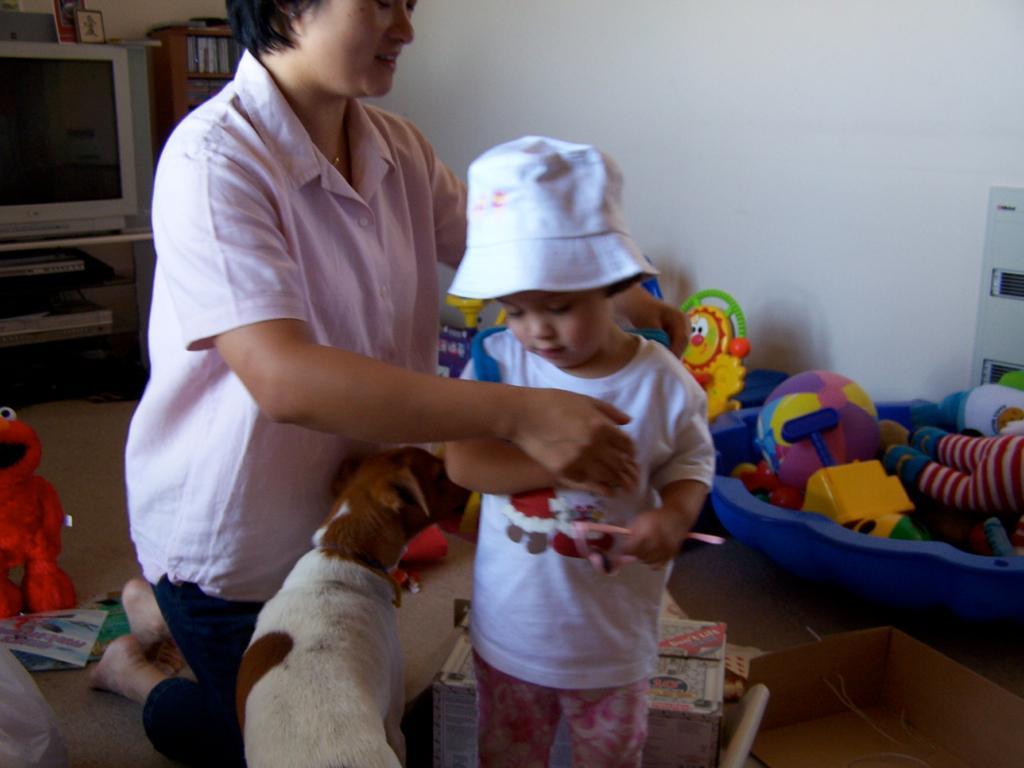In one or two sentences, can you explain what this image depicts? In this picture I can see a woman, a child and a dog in front. On the left bottom of this picture I can see a red color toy. In the background I can see many more toys and I see the wall. On the left top of this image I can see a TV. 